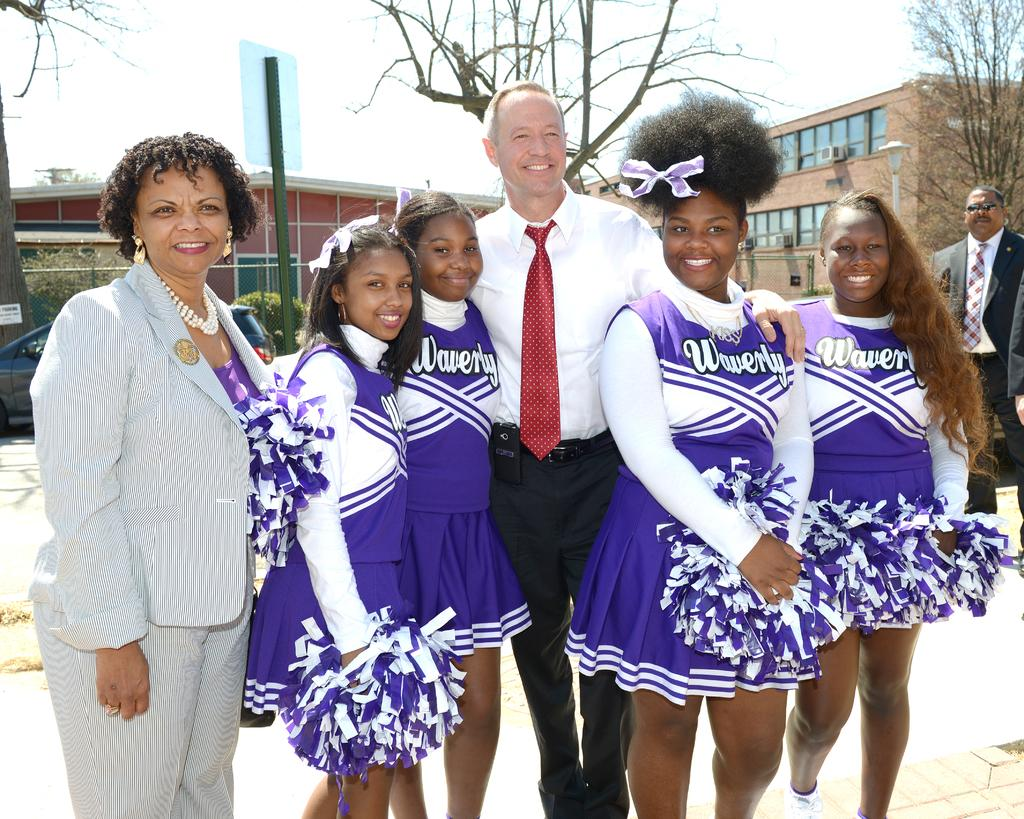<image>
Offer a succinct explanation of the picture presented. Several cheerleaders are wearing purple uniforms, representing Waverly. 